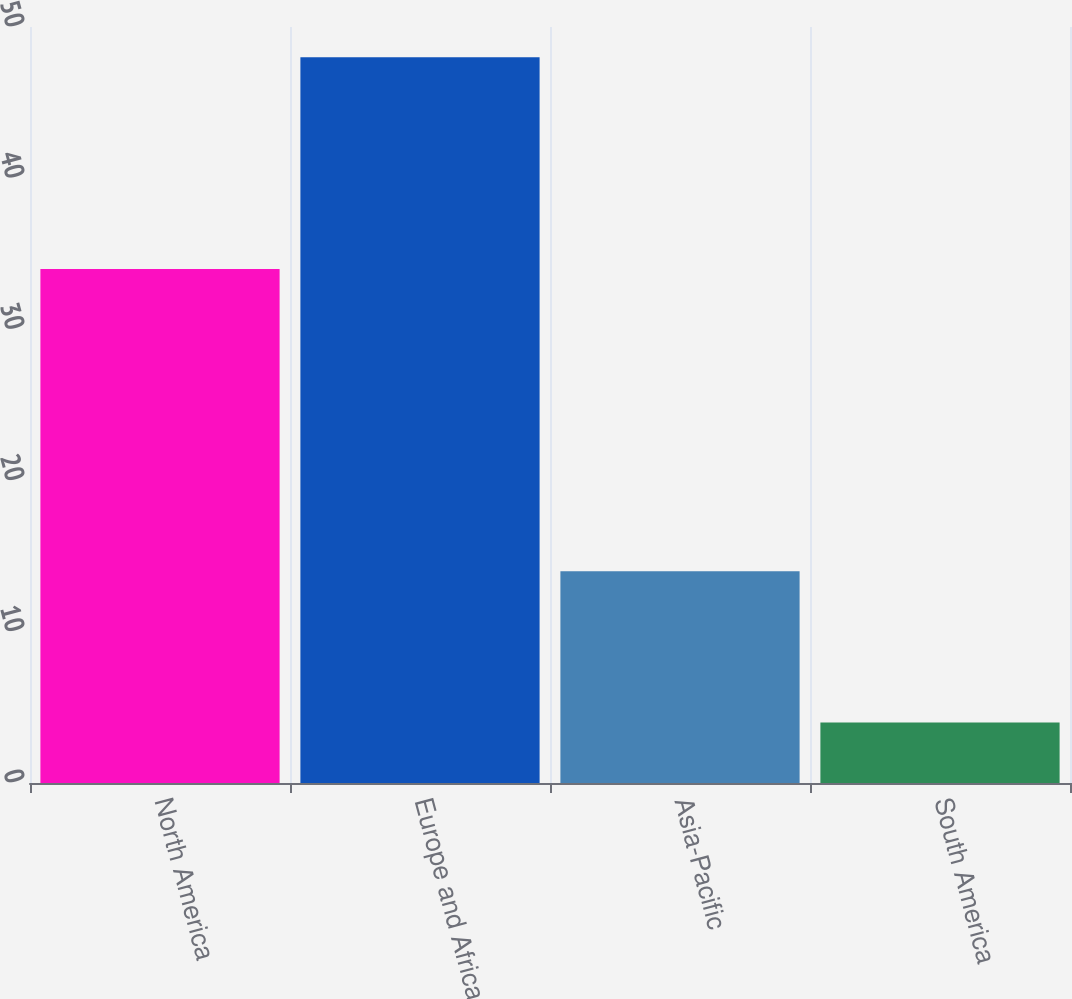Convert chart. <chart><loc_0><loc_0><loc_500><loc_500><bar_chart><fcel>North America<fcel>Europe and Africa<fcel>Asia-Pacific<fcel>South America<nl><fcel>34<fcel>48<fcel>14<fcel>4<nl></chart> 